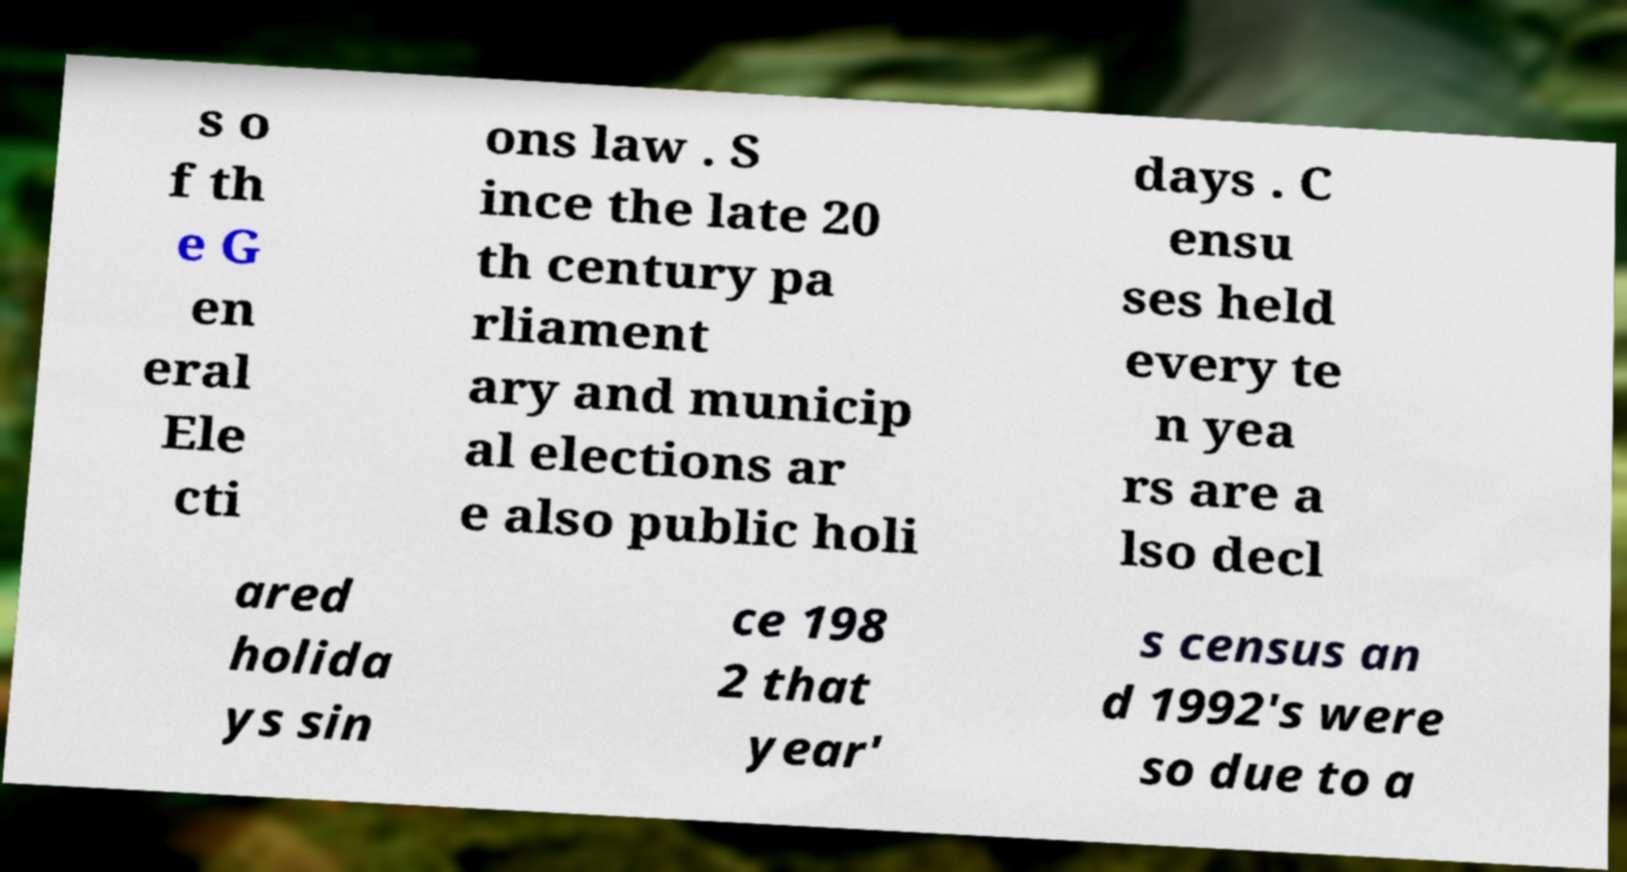For documentation purposes, I need the text within this image transcribed. Could you provide that? s o f th e G en eral Ele cti ons law . S ince the late 20 th century pa rliament ary and municip al elections ar e also public holi days . C ensu ses held every te n yea rs are a lso decl ared holida ys sin ce 198 2 that year' s census an d 1992's were so due to a 